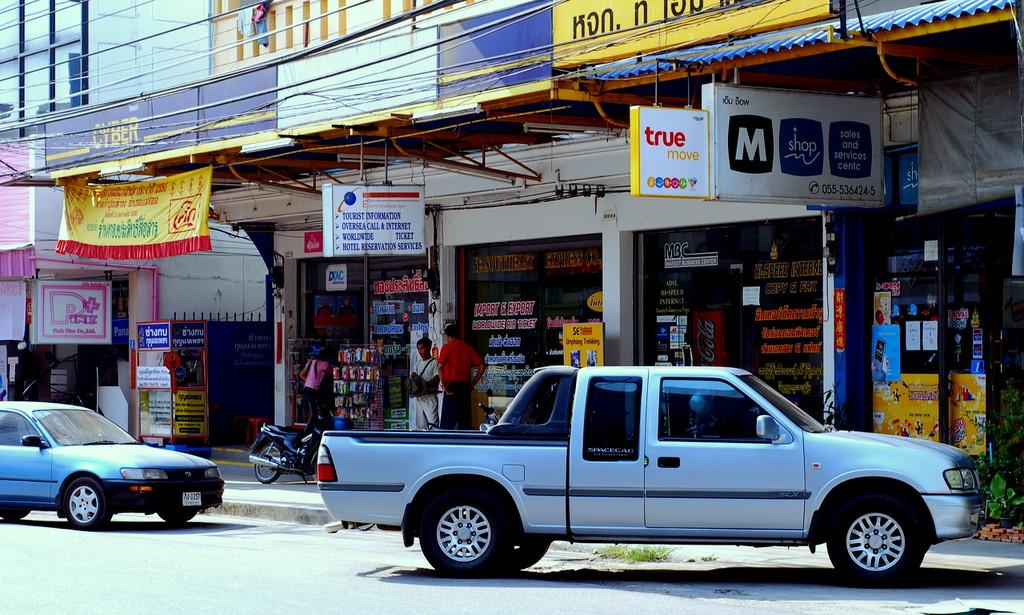How many cars are parked on the road in the image? There are two cars parked on the road in the image. Where are the cars located in the image? The cars are on the road in the image. What else can be seen in the image besides the cars? There are stores visible in the image. What type of crown is visible on the slope in the image? There is no crown or slope present in the image; it features two cars parked on the road and stores in the background. 